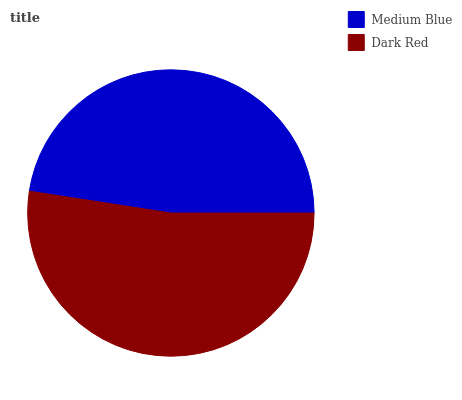Is Medium Blue the minimum?
Answer yes or no. Yes. Is Dark Red the maximum?
Answer yes or no. Yes. Is Dark Red the minimum?
Answer yes or no. No. Is Dark Red greater than Medium Blue?
Answer yes or no. Yes. Is Medium Blue less than Dark Red?
Answer yes or no. Yes. Is Medium Blue greater than Dark Red?
Answer yes or no. No. Is Dark Red less than Medium Blue?
Answer yes or no. No. Is Dark Red the high median?
Answer yes or no. Yes. Is Medium Blue the low median?
Answer yes or no. Yes. Is Medium Blue the high median?
Answer yes or no. No. Is Dark Red the low median?
Answer yes or no. No. 